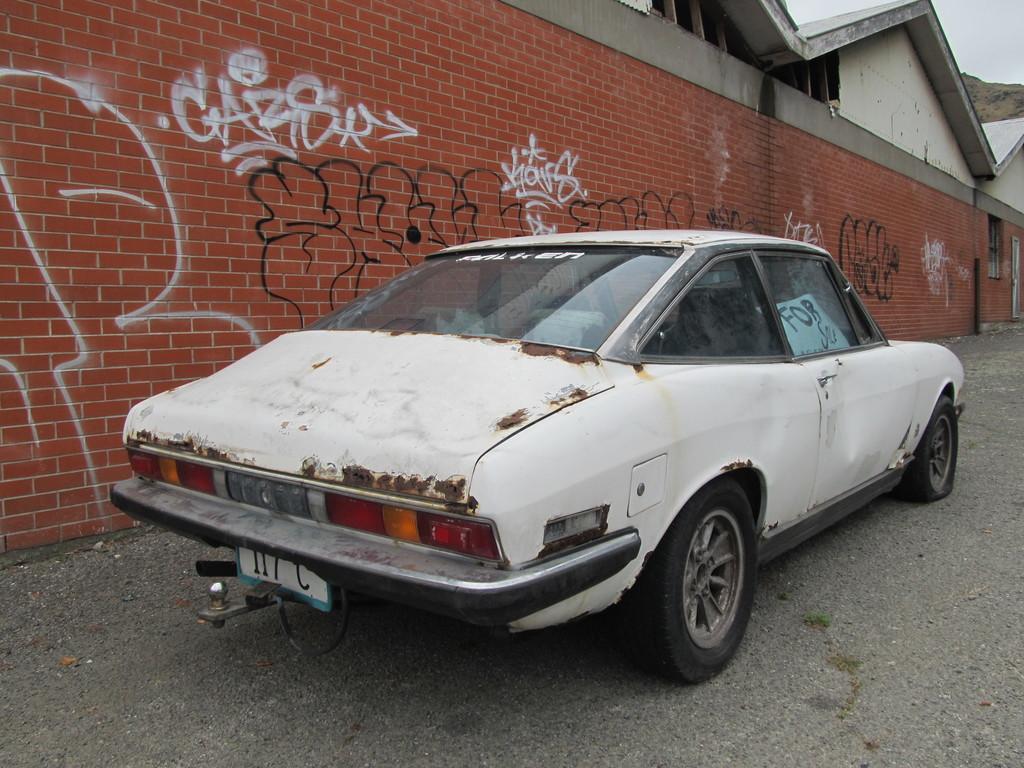How would you summarize this image in a sentence or two? In this image there is a white color car on the road, graffiti on the wall, buildings, hill,sky. 